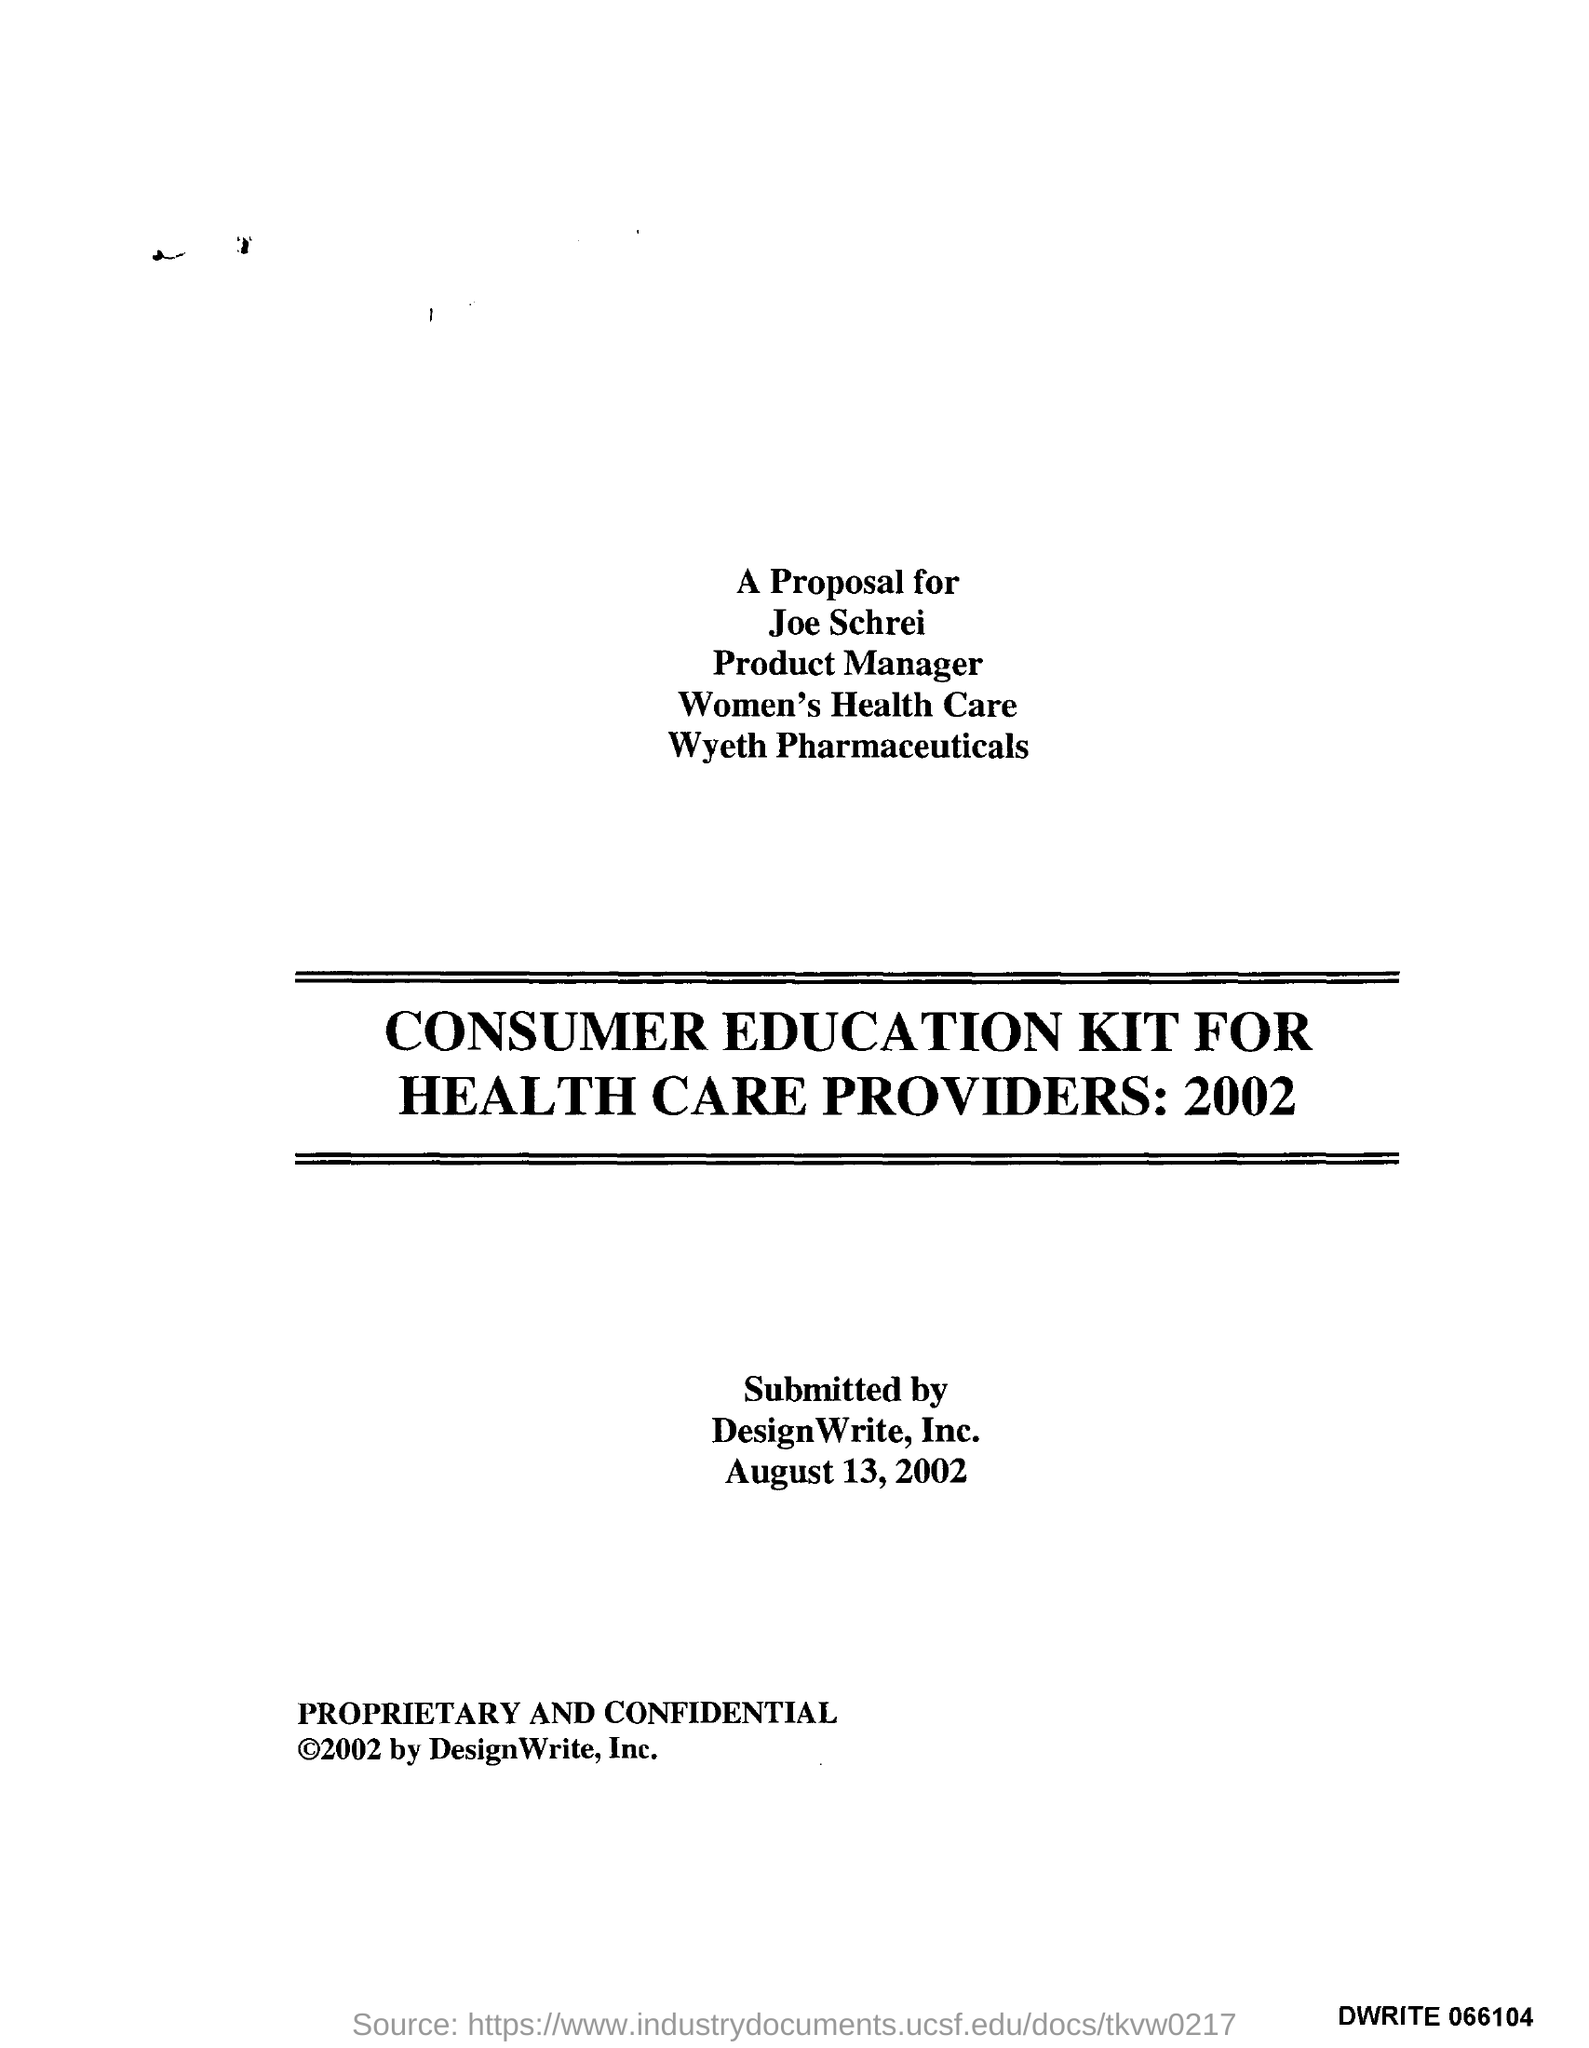What is the designation of joe schrei ?
Offer a very short reply. Product Manager. To whom this proposal is?
Offer a terse response. Joe Schrei. What is the name of pharmaceuticals
Make the answer very short. Wyeth Pharmaceuticals. 